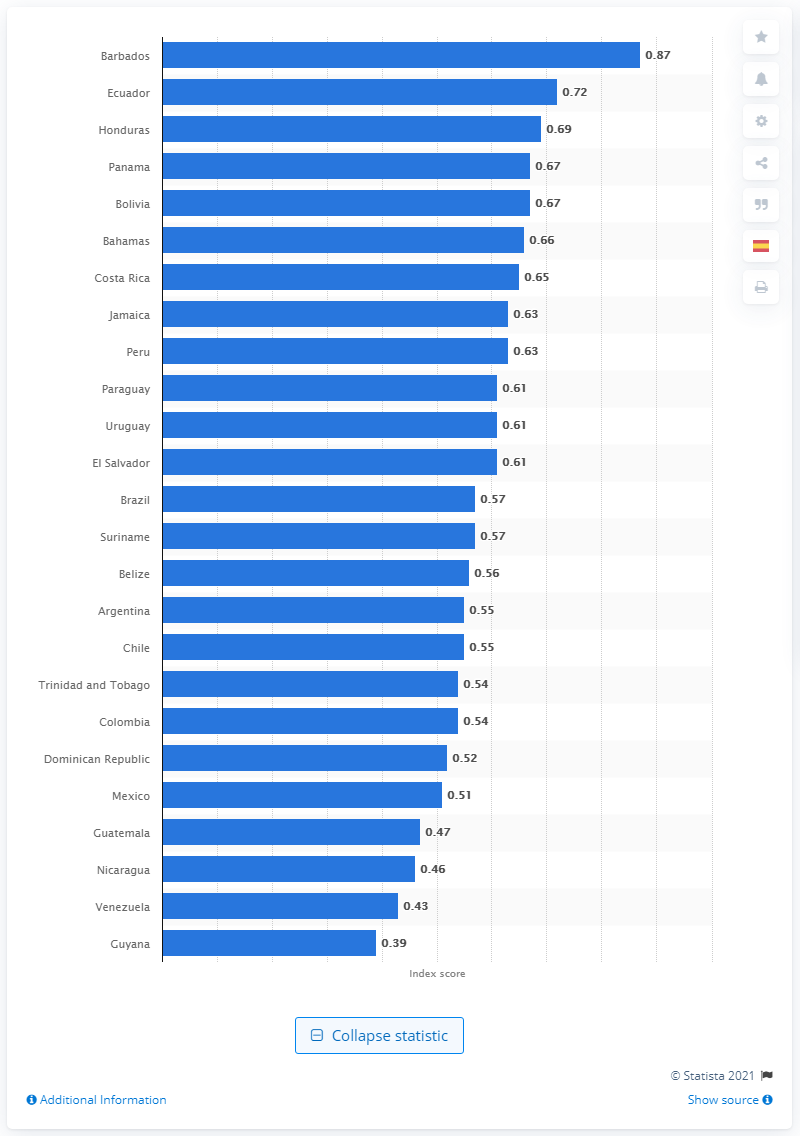Highlight a few significant elements in this photo. In 2021, the gender pay gap index score for Barbados was 0.87, indicating a moderate disparity between the average earnings of men and women. Barbados had the highest gender pay gap index among countries in Latin America and the Caribbean in 2021, according to the latest data. 